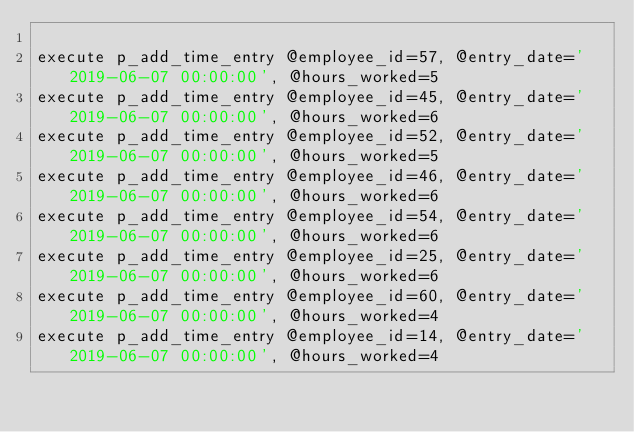<code> <loc_0><loc_0><loc_500><loc_500><_SQL_>
execute p_add_time_entry @employee_id=57, @entry_date='2019-06-07 00:00:00', @hours_worked=5
execute p_add_time_entry @employee_id=45, @entry_date='2019-06-07 00:00:00', @hours_worked=6
execute p_add_time_entry @employee_id=52, @entry_date='2019-06-07 00:00:00', @hours_worked=5
execute p_add_time_entry @employee_id=46, @entry_date='2019-06-07 00:00:00', @hours_worked=6
execute p_add_time_entry @employee_id=54, @entry_date='2019-06-07 00:00:00', @hours_worked=6
execute p_add_time_entry @employee_id=25, @entry_date='2019-06-07 00:00:00', @hours_worked=6
execute p_add_time_entry @employee_id=60, @entry_date='2019-06-07 00:00:00', @hours_worked=4
execute p_add_time_entry @employee_id=14, @entry_date='2019-06-07 00:00:00', @hours_worked=4

</code> 